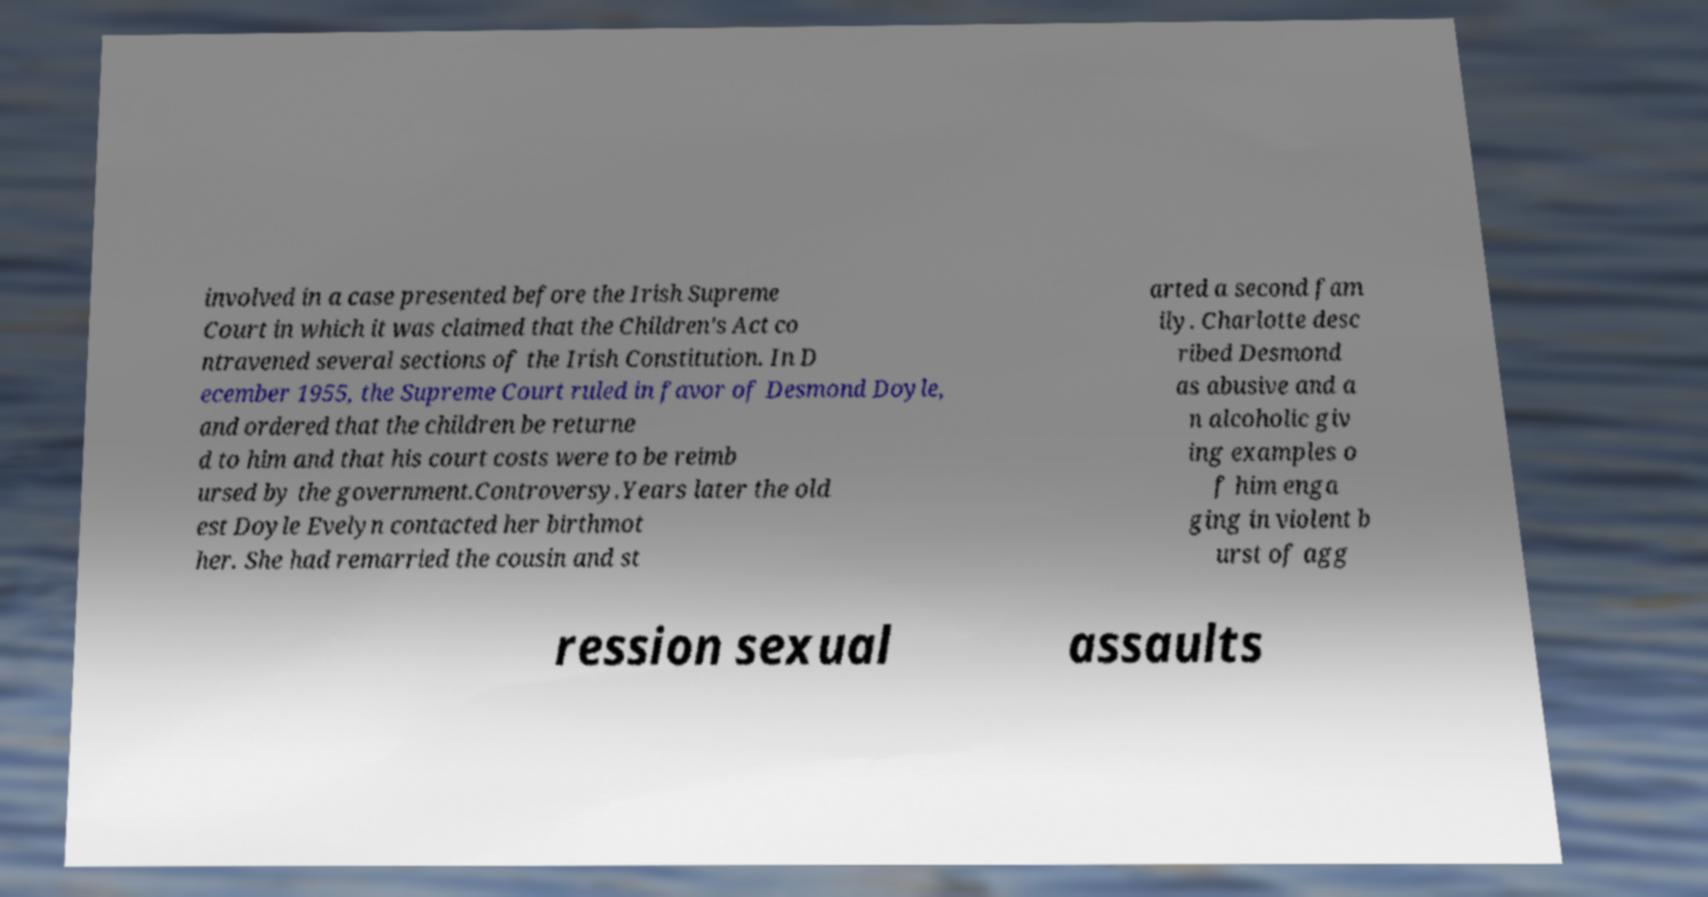For documentation purposes, I need the text within this image transcribed. Could you provide that? involved in a case presented before the Irish Supreme Court in which it was claimed that the Children's Act co ntravened several sections of the Irish Constitution. In D ecember 1955, the Supreme Court ruled in favor of Desmond Doyle, and ordered that the children be returne d to him and that his court costs were to be reimb ursed by the government.Controversy.Years later the old est Doyle Evelyn contacted her birthmot her. She had remarried the cousin and st arted a second fam ily. Charlotte desc ribed Desmond as abusive and a n alcoholic giv ing examples o f him enga ging in violent b urst of agg ression sexual assaults 